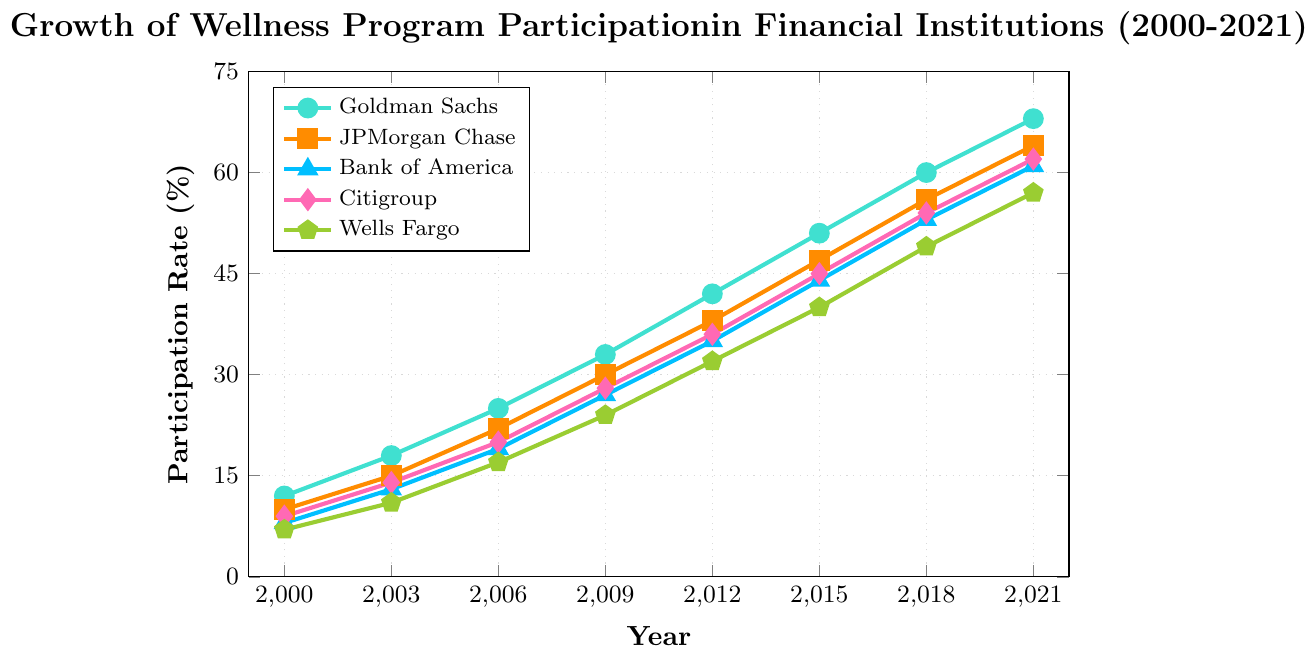Which financial institution had the highest participation rate in 2021? Scan the figure to identify the highest point among the lines plotted for 2021. The highest point corresponds to Goldman Sachs with a participation rate of 68%.
Answer: Goldman Sachs How did Bank of America's participation rate change between 2000 and 2021? Look at the values for Bank of America in 2000 and 2021. The participation rate in 2000 was 8% and in 2021 it was 61%. Calculate the difference: 61% - 8% = 53%.
Answer: Increased by 53% Which year saw the greatest increase in participation rate for Wells Fargo? Find the differences in participation rates of Wells Fargo between consecutive years and identify the year with the highest increase. The differences are 4% (2000-2003), 6% (2003-2006), 7% (2006-2009), 8% (2009-2012), 8% (2012-2015), 9% (2015-2018), and 8% (2018-2021). The greatest increase occurred in 2015-2018.
Answer: 2015-2018 Between 2009 and 2015, which financial institution had the largest increase in participation rate? Calculate the differences in participation rates for each institution between 2009 and 2015. Goldman Sachs: 51% - 33% = 18%, JPMorgan Chase: 47% - 30% = 17%, Bank of America: 44% - 27% = 17%, Citigroup: 45% - 28% = 17%, Wells Fargo: 40% - 24% = 16%. The largest increase was for Goldman Sachs.
Answer: Goldman Sachs What was the participation rate trend for Citigroup from 2000 to 2021? Observe the plotted line for Citigroup. The trend line shows an increase from 9% in 2000 to 62% in 2021, indicating a steadily rising trend over the years.
Answer: Steadily rising On average, how much did JPMorgan Chase's participation rate increase per year from 2000 to 2021? Calculate the total increase for JPMorgan Chase between 2000 and 2021: 64% - 10% = 54%. The number of years is 2021 - 2000 = 21. Divide the total increase by the number of years: 54% / 21 ≈ 2.57% per year.
Answer: 2.57% per year Which financial institution had the lowest participation rate in 2003? Review the participation rates for all institutions in 2003: Goldman Sachs (18%), JPMorgan Chase (15%), Bank of America (13%), Citigroup (14%), Wells Fargo (11%). Wells Fargo had the lowest participation rate.
Answer: Wells Fargo In which year did all five financial institutions show an upward trend in participation rate? Look at the lines plotted for each year and note when all five lines move upward simultaneously. This occurs consistently across all recorded years (from 2000 to 2021), indicating an overall upward trend for all years.
Answer: All years What is the difference in participation rates between Citigroup and Wells Fargo in 2021? Identify the participation rates of Citigroup (62%) and Wells Fargo (57%) in 2021 and calculate the difference: 62% - 57% = 5%.
Answer: 5% Which financial institution had the closest participation rate to the average participation rate of all institutions in 2018? Calculate the average participation rate for 2018: (60% + 56% + 53% + 54% + 49%) / 5 = 54.4%. Compare the average to each institution's 2018 rate. Citigroup's 54% is the closest to 54.4%.
Answer: Citigroup 